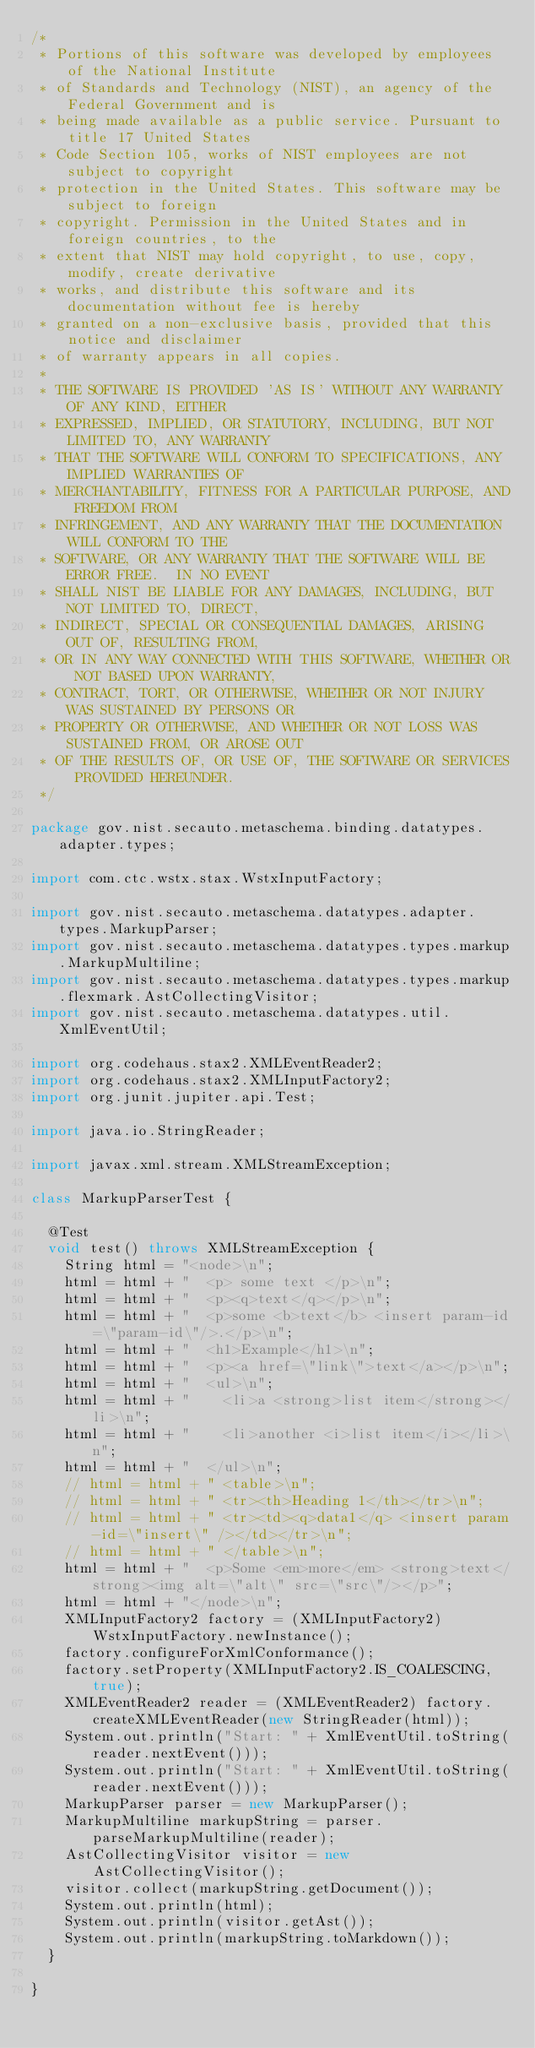<code> <loc_0><loc_0><loc_500><loc_500><_Java_>/*
 * Portions of this software was developed by employees of the National Institute
 * of Standards and Technology (NIST), an agency of the Federal Government and is
 * being made available as a public service. Pursuant to title 17 United States
 * Code Section 105, works of NIST employees are not subject to copyright
 * protection in the United States. This software may be subject to foreign
 * copyright. Permission in the United States and in foreign countries, to the
 * extent that NIST may hold copyright, to use, copy, modify, create derivative
 * works, and distribute this software and its documentation without fee is hereby
 * granted on a non-exclusive basis, provided that this notice and disclaimer
 * of warranty appears in all copies.
 *
 * THE SOFTWARE IS PROVIDED 'AS IS' WITHOUT ANY WARRANTY OF ANY KIND, EITHER
 * EXPRESSED, IMPLIED, OR STATUTORY, INCLUDING, BUT NOT LIMITED TO, ANY WARRANTY
 * THAT THE SOFTWARE WILL CONFORM TO SPECIFICATIONS, ANY IMPLIED WARRANTIES OF
 * MERCHANTABILITY, FITNESS FOR A PARTICULAR PURPOSE, AND FREEDOM FROM
 * INFRINGEMENT, AND ANY WARRANTY THAT THE DOCUMENTATION WILL CONFORM TO THE
 * SOFTWARE, OR ANY WARRANTY THAT THE SOFTWARE WILL BE ERROR FREE.  IN NO EVENT
 * SHALL NIST BE LIABLE FOR ANY DAMAGES, INCLUDING, BUT NOT LIMITED TO, DIRECT,
 * INDIRECT, SPECIAL OR CONSEQUENTIAL DAMAGES, ARISING OUT OF, RESULTING FROM,
 * OR IN ANY WAY CONNECTED WITH THIS SOFTWARE, WHETHER OR NOT BASED UPON WARRANTY,
 * CONTRACT, TORT, OR OTHERWISE, WHETHER OR NOT INJURY WAS SUSTAINED BY PERSONS OR
 * PROPERTY OR OTHERWISE, AND WHETHER OR NOT LOSS WAS SUSTAINED FROM, OR AROSE OUT
 * OF THE RESULTS OF, OR USE OF, THE SOFTWARE OR SERVICES PROVIDED HEREUNDER.
 */

package gov.nist.secauto.metaschema.binding.datatypes.adapter.types;

import com.ctc.wstx.stax.WstxInputFactory;

import gov.nist.secauto.metaschema.datatypes.adapter.types.MarkupParser;
import gov.nist.secauto.metaschema.datatypes.types.markup.MarkupMultiline;
import gov.nist.secauto.metaschema.datatypes.types.markup.flexmark.AstCollectingVisitor;
import gov.nist.secauto.metaschema.datatypes.util.XmlEventUtil;

import org.codehaus.stax2.XMLEventReader2;
import org.codehaus.stax2.XMLInputFactory2;
import org.junit.jupiter.api.Test;

import java.io.StringReader;

import javax.xml.stream.XMLStreamException;

class MarkupParserTest {

  @Test
  void test() throws XMLStreamException {
    String html = "<node>\n";
    html = html + "  <p> some text </p>\n";
    html = html + "  <p><q>text</q></p>\n";
    html = html + "  <p>some <b>text</b> <insert param-id=\"param-id\"/>.</p>\n";
    html = html + "  <h1>Example</h1>\n";
    html = html + "  <p><a href=\"link\">text</a></p>\n";
    html = html + "  <ul>\n";
    html = html + "    <li>a <strong>list item</strong></li>\n";
    html = html + "    <li>another <i>list item</i></li>\n";
    html = html + "  </ul>\n";
    // html = html + " <table>\n";
    // html = html + " <tr><th>Heading 1</th></tr>\n";
    // html = html + " <tr><td><q>data1</q> <insert param-id=\"insert\" /></td></tr>\n";
    // html = html + " </table>\n";
    html = html + "  <p>Some <em>more</em> <strong>text</strong><img alt=\"alt\" src=\"src\"/></p>";
    html = html + "</node>\n";
    XMLInputFactory2 factory = (XMLInputFactory2) WstxInputFactory.newInstance();
    factory.configureForXmlConformance();
    factory.setProperty(XMLInputFactory2.IS_COALESCING, true);
    XMLEventReader2 reader = (XMLEventReader2) factory.createXMLEventReader(new StringReader(html));
    System.out.println("Start: " + XmlEventUtil.toString(reader.nextEvent()));
    System.out.println("Start: " + XmlEventUtil.toString(reader.nextEvent()));
    MarkupParser parser = new MarkupParser();
    MarkupMultiline markupString = parser.parseMarkupMultiline(reader);
    AstCollectingVisitor visitor = new AstCollectingVisitor();
    visitor.collect(markupString.getDocument());
    System.out.println(html);
    System.out.println(visitor.getAst());
    System.out.println(markupString.toMarkdown());
  }

}
</code> 